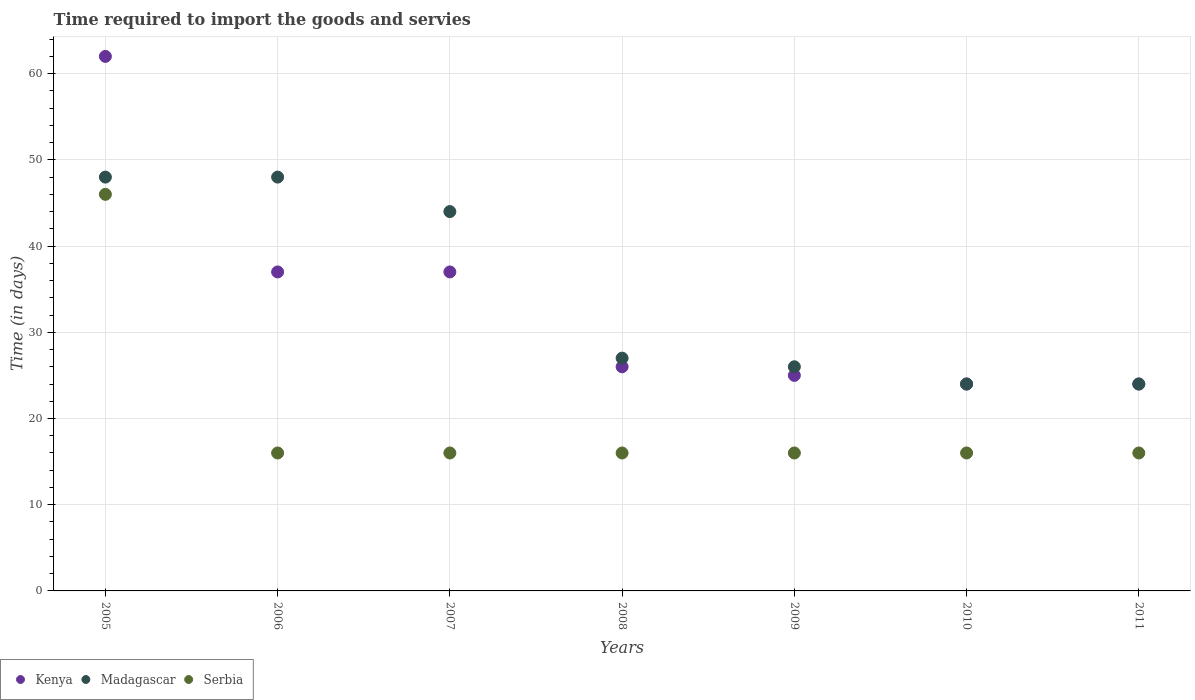How many different coloured dotlines are there?
Provide a short and direct response. 3. Is the number of dotlines equal to the number of legend labels?
Provide a succinct answer. Yes. What is the number of days required to import the goods and services in Serbia in 2007?
Give a very brief answer. 16. Across all years, what is the maximum number of days required to import the goods and services in Madagascar?
Offer a terse response. 48. Across all years, what is the minimum number of days required to import the goods and services in Madagascar?
Ensure brevity in your answer.  24. In which year was the number of days required to import the goods and services in Madagascar maximum?
Offer a very short reply. 2005. What is the total number of days required to import the goods and services in Serbia in the graph?
Ensure brevity in your answer.  142. What is the difference between the number of days required to import the goods and services in Kenya in 2005 and that in 2009?
Provide a succinct answer. 37. What is the difference between the number of days required to import the goods and services in Madagascar in 2006 and the number of days required to import the goods and services in Kenya in 2007?
Give a very brief answer. 11. What is the average number of days required to import the goods and services in Kenya per year?
Your answer should be compact. 33.57. In the year 2005, what is the difference between the number of days required to import the goods and services in Serbia and number of days required to import the goods and services in Madagascar?
Keep it short and to the point. -2. In how many years, is the number of days required to import the goods and services in Kenya greater than 50 days?
Offer a terse response. 1. What is the ratio of the number of days required to import the goods and services in Madagascar in 2005 to that in 2009?
Your answer should be compact. 1.85. Is the number of days required to import the goods and services in Serbia in 2009 less than that in 2011?
Give a very brief answer. No. What is the difference between the highest and the second highest number of days required to import the goods and services in Madagascar?
Provide a short and direct response. 0. What is the difference between the highest and the lowest number of days required to import the goods and services in Kenya?
Your answer should be compact. 38. Is it the case that in every year, the sum of the number of days required to import the goods and services in Serbia and number of days required to import the goods and services in Madagascar  is greater than the number of days required to import the goods and services in Kenya?
Your answer should be compact. Yes. Is the number of days required to import the goods and services in Madagascar strictly less than the number of days required to import the goods and services in Kenya over the years?
Your answer should be very brief. No. What is the difference between two consecutive major ticks on the Y-axis?
Your response must be concise. 10. Are the values on the major ticks of Y-axis written in scientific E-notation?
Provide a short and direct response. No. Does the graph contain any zero values?
Offer a very short reply. No. Where does the legend appear in the graph?
Provide a short and direct response. Bottom left. How are the legend labels stacked?
Your response must be concise. Horizontal. What is the title of the graph?
Give a very brief answer. Time required to import the goods and servies. What is the label or title of the Y-axis?
Your answer should be compact. Time (in days). What is the Time (in days) in Kenya in 2005?
Your response must be concise. 62. What is the Time (in days) in Madagascar in 2005?
Make the answer very short. 48. What is the Time (in days) of Madagascar in 2006?
Offer a terse response. 48. What is the Time (in days) of Kenya in 2007?
Make the answer very short. 37. What is the Time (in days) of Serbia in 2007?
Make the answer very short. 16. What is the Time (in days) in Madagascar in 2010?
Your answer should be very brief. 24. Across all years, what is the maximum Time (in days) in Serbia?
Ensure brevity in your answer.  46. Across all years, what is the minimum Time (in days) of Kenya?
Keep it short and to the point. 24. Across all years, what is the minimum Time (in days) in Serbia?
Your response must be concise. 16. What is the total Time (in days) of Kenya in the graph?
Keep it short and to the point. 235. What is the total Time (in days) of Madagascar in the graph?
Provide a short and direct response. 241. What is the total Time (in days) in Serbia in the graph?
Provide a succinct answer. 142. What is the difference between the Time (in days) in Serbia in 2005 and that in 2006?
Your response must be concise. 30. What is the difference between the Time (in days) in Serbia in 2005 and that in 2008?
Provide a succinct answer. 30. What is the difference between the Time (in days) of Madagascar in 2005 and that in 2010?
Provide a short and direct response. 24. What is the difference between the Time (in days) of Serbia in 2005 and that in 2010?
Offer a terse response. 30. What is the difference between the Time (in days) in Serbia in 2005 and that in 2011?
Your response must be concise. 30. What is the difference between the Time (in days) of Kenya in 2006 and that in 2007?
Ensure brevity in your answer.  0. What is the difference between the Time (in days) in Kenya in 2006 and that in 2008?
Your response must be concise. 11. What is the difference between the Time (in days) in Madagascar in 2006 and that in 2008?
Ensure brevity in your answer.  21. What is the difference between the Time (in days) in Serbia in 2006 and that in 2010?
Your answer should be very brief. 0. What is the difference between the Time (in days) of Kenya in 2006 and that in 2011?
Keep it short and to the point. 13. What is the difference between the Time (in days) of Madagascar in 2007 and that in 2008?
Ensure brevity in your answer.  17. What is the difference between the Time (in days) in Serbia in 2007 and that in 2009?
Your response must be concise. 0. What is the difference between the Time (in days) of Serbia in 2007 and that in 2010?
Provide a succinct answer. 0. What is the difference between the Time (in days) of Kenya in 2007 and that in 2011?
Your answer should be compact. 13. What is the difference between the Time (in days) of Madagascar in 2007 and that in 2011?
Give a very brief answer. 20. What is the difference between the Time (in days) of Serbia in 2007 and that in 2011?
Ensure brevity in your answer.  0. What is the difference between the Time (in days) of Madagascar in 2008 and that in 2009?
Your answer should be compact. 1. What is the difference between the Time (in days) in Serbia in 2008 and that in 2009?
Make the answer very short. 0. What is the difference between the Time (in days) in Kenya in 2008 and that in 2010?
Ensure brevity in your answer.  2. What is the difference between the Time (in days) of Kenya in 2008 and that in 2011?
Keep it short and to the point. 2. What is the difference between the Time (in days) of Kenya in 2009 and that in 2010?
Make the answer very short. 1. What is the difference between the Time (in days) of Madagascar in 2009 and that in 2010?
Provide a succinct answer. 2. What is the difference between the Time (in days) in Serbia in 2009 and that in 2011?
Ensure brevity in your answer.  0. What is the difference between the Time (in days) in Serbia in 2010 and that in 2011?
Your answer should be very brief. 0. What is the difference between the Time (in days) of Madagascar in 2005 and the Time (in days) of Serbia in 2006?
Your response must be concise. 32. What is the difference between the Time (in days) of Kenya in 2005 and the Time (in days) of Madagascar in 2007?
Your answer should be compact. 18. What is the difference between the Time (in days) of Kenya in 2005 and the Time (in days) of Serbia in 2008?
Provide a short and direct response. 46. What is the difference between the Time (in days) in Madagascar in 2005 and the Time (in days) in Serbia in 2008?
Make the answer very short. 32. What is the difference between the Time (in days) of Kenya in 2005 and the Time (in days) of Madagascar in 2009?
Make the answer very short. 36. What is the difference between the Time (in days) in Madagascar in 2005 and the Time (in days) in Serbia in 2009?
Keep it short and to the point. 32. What is the difference between the Time (in days) in Kenya in 2005 and the Time (in days) in Madagascar in 2010?
Give a very brief answer. 38. What is the difference between the Time (in days) of Kenya in 2005 and the Time (in days) of Madagascar in 2011?
Your response must be concise. 38. What is the difference between the Time (in days) of Madagascar in 2005 and the Time (in days) of Serbia in 2011?
Your answer should be very brief. 32. What is the difference between the Time (in days) of Kenya in 2006 and the Time (in days) of Madagascar in 2007?
Make the answer very short. -7. What is the difference between the Time (in days) in Madagascar in 2006 and the Time (in days) in Serbia in 2007?
Your response must be concise. 32. What is the difference between the Time (in days) of Kenya in 2006 and the Time (in days) of Madagascar in 2008?
Offer a terse response. 10. What is the difference between the Time (in days) of Kenya in 2006 and the Time (in days) of Serbia in 2008?
Provide a succinct answer. 21. What is the difference between the Time (in days) in Madagascar in 2006 and the Time (in days) in Serbia in 2009?
Ensure brevity in your answer.  32. What is the difference between the Time (in days) in Kenya in 2006 and the Time (in days) in Madagascar in 2010?
Offer a terse response. 13. What is the difference between the Time (in days) of Kenya in 2006 and the Time (in days) of Serbia in 2010?
Give a very brief answer. 21. What is the difference between the Time (in days) of Madagascar in 2006 and the Time (in days) of Serbia in 2010?
Give a very brief answer. 32. What is the difference between the Time (in days) of Kenya in 2006 and the Time (in days) of Madagascar in 2011?
Provide a succinct answer. 13. What is the difference between the Time (in days) in Kenya in 2006 and the Time (in days) in Serbia in 2011?
Your answer should be very brief. 21. What is the difference between the Time (in days) of Kenya in 2007 and the Time (in days) of Madagascar in 2008?
Provide a short and direct response. 10. What is the difference between the Time (in days) of Madagascar in 2007 and the Time (in days) of Serbia in 2008?
Ensure brevity in your answer.  28. What is the difference between the Time (in days) of Kenya in 2007 and the Time (in days) of Madagascar in 2009?
Your response must be concise. 11. What is the difference between the Time (in days) in Kenya in 2007 and the Time (in days) in Serbia in 2009?
Give a very brief answer. 21. What is the difference between the Time (in days) in Madagascar in 2007 and the Time (in days) in Serbia in 2009?
Offer a very short reply. 28. What is the difference between the Time (in days) in Kenya in 2007 and the Time (in days) in Madagascar in 2010?
Provide a short and direct response. 13. What is the difference between the Time (in days) of Madagascar in 2007 and the Time (in days) of Serbia in 2010?
Your response must be concise. 28. What is the difference between the Time (in days) in Kenya in 2007 and the Time (in days) in Serbia in 2011?
Your response must be concise. 21. What is the difference between the Time (in days) in Madagascar in 2007 and the Time (in days) in Serbia in 2011?
Provide a succinct answer. 28. What is the difference between the Time (in days) in Kenya in 2008 and the Time (in days) in Madagascar in 2009?
Your response must be concise. 0. What is the difference between the Time (in days) in Kenya in 2008 and the Time (in days) in Madagascar in 2010?
Provide a succinct answer. 2. What is the difference between the Time (in days) in Kenya in 2008 and the Time (in days) in Serbia in 2010?
Provide a succinct answer. 10. What is the difference between the Time (in days) of Madagascar in 2008 and the Time (in days) of Serbia in 2010?
Ensure brevity in your answer.  11. What is the difference between the Time (in days) of Kenya in 2009 and the Time (in days) of Madagascar in 2011?
Your response must be concise. 1. What is the difference between the Time (in days) in Kenya in 2009 and the Time (in days) in Serbia in 2011?
Ensure brevity in your answer.  9. What is the difference between the Time (in days) in Kenya in 2010 and the Time (in days) in Madagascar in 2011?
Your answer should be very brief. 0. What is the average Time (in days) in Kenya per year?
Offer a very short reply. 33.57. What is the average Time (in days) of Madagascar per year?
Ensure brevity in your answer.  34.43. What is the average Time (in days) in Serbia per year?
Offer a terse response. 20.29. In the year 2005, what is the difference between the Time (in days) in Kenya and Time (in days) in Madagascar?
Give a very brief answer. 14. In the year 2006, what is the difference between the Time (in days) of Kenya and Time (in days) of Madagascar?
Make the answer very short. -11. In the year 2006, what is the difference between the Time (in days) in Kenya and Time (in days) in Serbia?
Give a very brief answer. 21. In the year 2006, what is the difference between the Time (in days) in Madagascar and Time (in days) in Serbia?
Your response must be concise. 32. In the year 2007, what is the difference between the Time (in days) of Kenya and Time (in days) of Serbia?
Your response must be concise. 21. In the year 2007, what is the difference between the Time (in days) in Madagascar and Time (in days) in Serbia?
Make the answer very short. 28. In the year 2008, what is the difference between the Time (in days) of Madagascar and Time (in days) of Serbia?
Offer a very short reply. 11. In the year 2011, what is the difference between the Time (in days) in Madagascar and Time (in days) in Serbia?
Ensure brevity in your answer.  8. What is the ratio of the Time (in days) of Kenya in 2005 to that in 2006?
Your answer should be very brief. 1.68. What is the ratio of the Time (in days) of Madagascar in 2005 to that in 2006?
Make the answer very short. 1. What is the ratio of the Time (in days) of Serbia in 2005 to that in 2006?
Provide a short and direct response. 2.88. What is the ratio of the Time (in days) of Kenya in 2005 to that in 2007?
Provide a short and direct response. 1.68. What is the ratio of the Time (in days) of Serbia in 2005 to that in 2007?
Ensure brevity in your answer.  2.88. What is the ratio of the Time (in days) in Kenya in 2005 to that in 2008?
Your answer should be very brief. 2.38. What is the ratio of the Time (in days) of Madagascar in 2005 to that in 2008?
Make the answer very short. 1.78. What is the ratio of the Time (in days) in Serbia in 2005 to that in 2008?
Your answer should be compact. 2.88. What is the ratio of the Time (in days) of Kenya in 2005 to that in 2009?
Give a very brief answer. 2.48. What is the ratio of the Time (in days) of Madagascar in 2005 to that in 2009?
Your answer should be compact. 1.85. What is the ratio of the Time (in days) in Serbia in 2005 to that in 2009?
Provide a succinct answer. 2.88. What is the ratio of the Time (in days) of Kenya in 2005 to that in 2010?
Make the answer very short. 2.58. What is the ratio of the Time (in days) of Serbia in 2005 to that in 2010?
Provide a succinct answer. 2.88. What is the ratio of the Time (in days) in Kenya in 2005 to that in 2011?
Give a very brief answer. 2.58. What is the ratio of the Time (in days) in Serbia in 2005 to that in 2011?
Your answer should be very brief. 2.88. What is the ratio of the Time (in days) in Madagascar in 2006 to that in 2007?
Offer a very short reply. 1.09. What is the ratio of the Time (in days) in Kenya in 2006 to that in 2008?
Your response must be concise. 1.42. What is the ratio of the Time (in days) of Madagascar in 2006 to that in 2008?
Provide a succinct answer. 1.78. What is the ratio of the Time (in days) of Kenya in 2006 to that in 2009?
Your answer should be very brief. 1.48. What is the ratio of the Time (in days) in Madagascar in 2006 to that in 2009?
Make the answer very short. 1.85. What is the ratio of the Time (in days) of Serbia in 2006 to that in 2009?
Your response must be concise. 1. What is the ratio of the Time (in days) of Kenya in 2006 to that in 2010?
Give a very brief answer. 1.54. What is the ratio of the Time (in days) in Madagascar in 2006 to that in 2010?
Give a very brief answer. 2. What is the ratio of the Time (in days) of Kenya in 2006 to that in 2011?
Your response must be concise. 1.54. What is the ratio of the Time (in days) in Madagascar in 2006 to that in 2011?
Your answer should be compact. 2. What is the ratio of the Time (in days) of Serbia in 2006 to that in 2011?
Give a very brief answer. 1. What is the ratio of the Time (in days) in Kenya in 2007 to that in 2008?
Your response must be concise. 1.42. What is the ratio of the Time (in days) in Madagascar in 2007 to that in 2008?
Ensure brevity in your answer.  1.63. What is the ratio of the Time (in days) of Kenya in 2007 to that in 2009?
Provide a short and direct response. 1.48. What is the ratio of the Time (in days) of Madagascar in 2007 to that in 2009?
Provide a short and direct response. 1.69. What is the ratio of the Time (in days) in Kenya in 2007 to that in 2010?
Offer a very short reply. 1.54. What is the ratio of the Time (in days) of Madagascar in 2007 to that in 2010?
Make the answer very short. 1.83. What is the ratio of the Time (in days) of Kenya in 2007 to that in 2011?
Your answer should be very brief. 1.54. What is the ratio of the Time (in days) in Madagascar in 2007 to that in 2011?
Your answer should be compact. 1.83. What is the ratio of the Time (in days) in Serbia in 2007 to that in 2011?
Provide a short and direct response. 1. What is the ratio of the Time (in days) in Madagascar in 2008 to that in 2009?
Keep it short and to the point. 1.04. What is the ratio of the Time (in days) of Madagascar in 2008 to that in 2010?
Your answer should be compact. 1.12. What is the ratio of the Time (in days) of Serbia in 2008 to that in 2010?
Keep it short and to the point. 1. What is the ratio of the Time (in days) of Kenya in 2008 to that in 2011?
Your response must be concise. 1.08. What is the ratio of the Time (in days) of Kenya in 2009 to that in 2010?
Offer a very short reply. 1.04. What is the ratio of the Time (in days) in Kenya in 2009 to that in 2011?
Provide a succinct answer. 1.04. What is the ratio of the Time (in days) of Kenya in 2010 to that in 2011?
Provide a succinct answer. 1. What is the ratio of the Time (in days) of Madagascar in 2010 to that in 2011?
Provide a succinct answer. 1. What is the difference between the highest and the second highest Time (in days) of Madagascar?
Make the answer very short. 0. What is the difference between the highest and the second highest Time (in days) of Serbia?
Your response must be concise. 30. What is the difference between the highest and the lowest Time (in days) of Madagascar?
Ensure brevity in your answer.  24. What is the difference between the highest and the lowest Time (in days) of Serbia?
Keep it short and to the point. 30. 